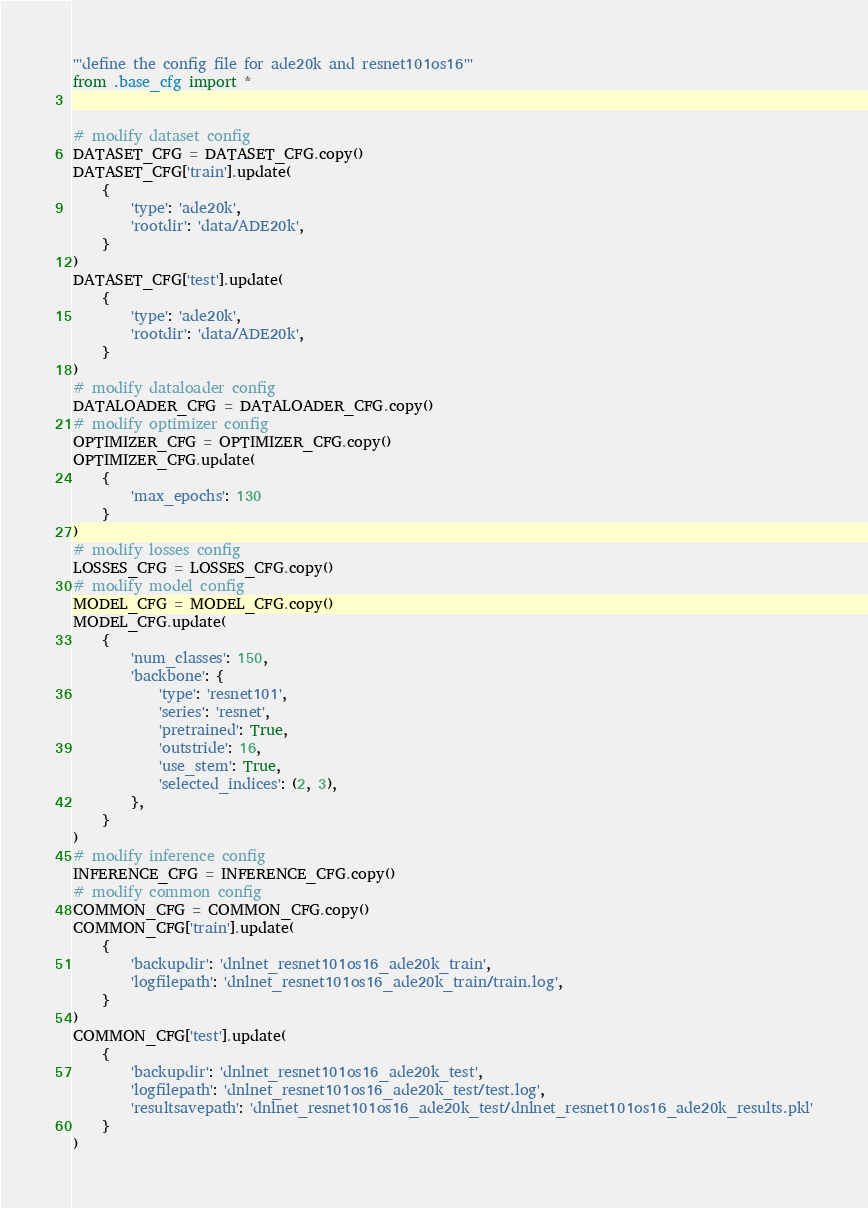Convert code to text. <code><loc_0><loc_0><loc_500><loc_500><_Python_>'''define the config file for ade20k and resnet101os16'''
from .base_cfg import *


# modify dataset config
DATASET_CFG = DATASET_CFG.copy()
DATASET_CFG['train'].update(
    {
        'type': 'ade20k',
        'rootdir': 'data/ADE20k',
    }
)
DATASET_CFG['test'].update(
    {
        'type': 'ade20k',
        'rootdir': 'data/ADE20k',
    }
)
# modify dataloader config
DATALOADER_CFG = DATALOADER_CFG.copy()
# modify optimizer config
OPTIMIZER_CFG = OPTIMIZER_CFG.copy()
OPTIMIZER_CFG.update(
    {
        'max_epochs': 130
    }
)
# modify losses config
LOSSES_CFG = LOSSES_CFG.copy()
# modify model config
MODEL_CFG = MODEL_CFG.copy()
MODEL_CFG.update(
    {
        'num_classes': 150,
        'backbone': {
            'type': 'resnet101',
            'series': 'resnet',
            'pretrained': True,
            'outstride': 16,
            'use_stem': True,
            'selected_indices': (2, 3),
        },
    }
)
# modify inference config
INFERENCE_CFG = INFERENCE_CFG.copy()
# modify common config
COMMON_CFG = COMMON_CFG.copy()
COMMON_CFG['train'].update(
    {
        'backupdir': 'dnlnet_resnet101os16_ade20k_train',
        'logfilepath': 'dnlnet_resnet101os16_ade20k_train/train.log',
    }
)
COMMON_CFG['test'].update(
    {
        'backupdir': 'dnlnet_resnet101os16_ade20k_test',
        'logfilepath': 'dnlnet_resnet101os16_ade20k_test/test.log',
        'resultsavepath': 'dnlnet_resnet101os16_ade20k_test/dnlnet_resnet101os16_ade20k_results.pkl'
    }
)</code> 